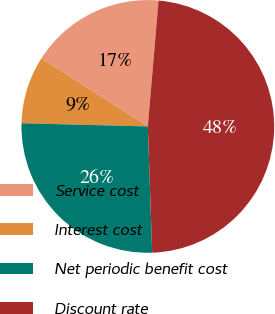Convert chart to OTSL. <chart><loc_0><loc_0><loc_500><loc_500><pie_chart><fcel>Service cost<fcel>Interest cost<fcel>Net periodic benefit cost<fcel>Discount rate<nl><fcel>17.3%<fcel>8.65%<fcel>25.95%<fcel>48.1%<nl></chart> 